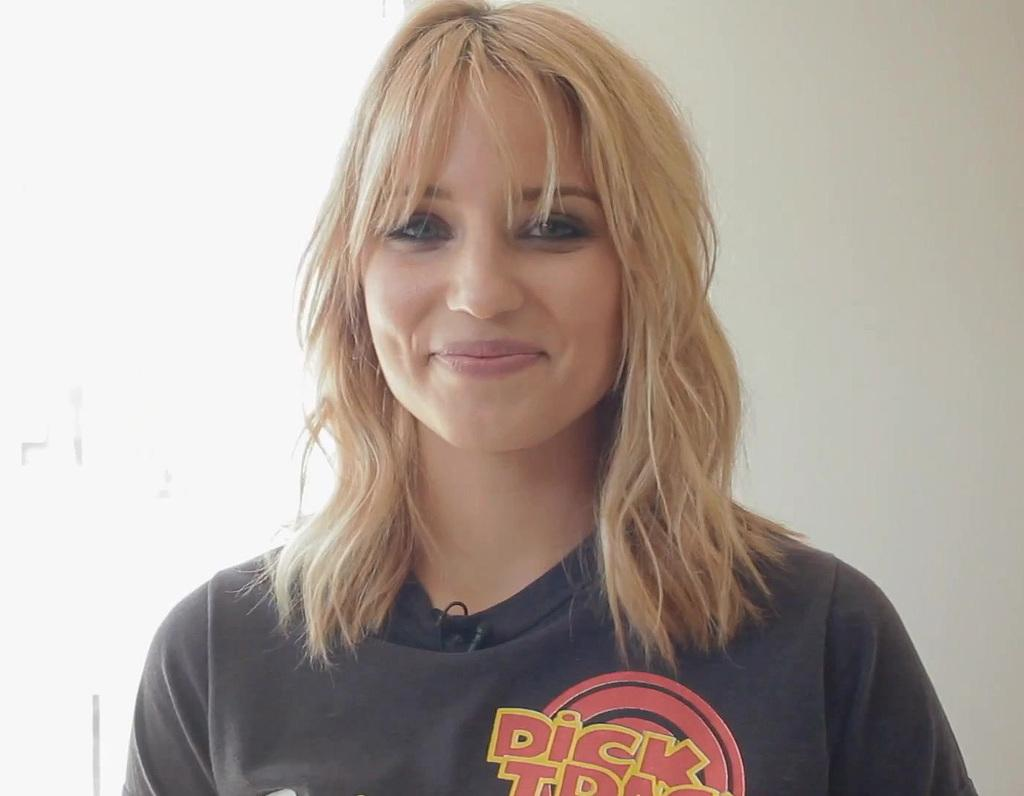<image>
Offer a succinct explanation of the picture presented. a beautiful blonde haired lady wearing a dick tracy shit 